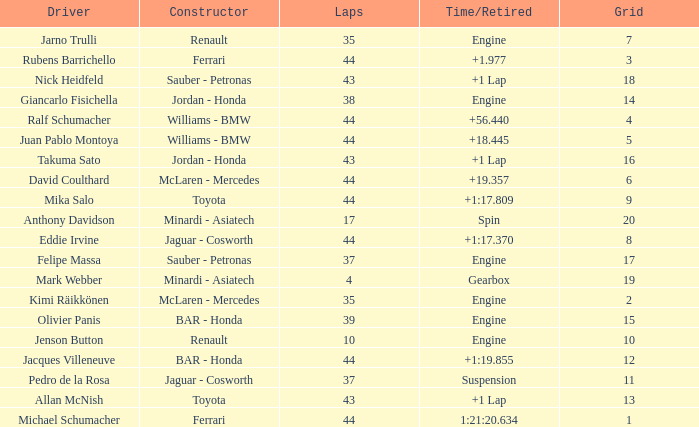What was the fewest laps for somone who finished +18.445? 44.0. Parse the full table. {'header': ['Driver', 'Constructor', 'Laps', 'Time/Retired', 'Grid'], 'rows': [['Jarno Trulli', 'Renault', '35', 'Engine', '7'], ['Rubens Barrichello', 'Ferrari', '44', '+1.977', '3'], ['Nick Heidfeld', 'Sauber - Petronas', '43', '+1 Lap', '18'], ['Giancarlo Fisichella', 'Jordan - Honda', '38', 'Engine', '14'], ['Ralf Schumacher', 'Williams - BMW', '44', '+56.440', '4'], ['Juan Pablo Montoya', 'Williams - BMW', '44', '+18.445', '5'], ['Takuma Sato', 'Jordan - Honda', '43', '+1 Lap', '16'], ['David Coulthard', 'McLaren - Mercedes', '44', '+19.357', '6'], ['Mika Salo', 'Toyota', '44', '+1:17.809', '9'], ['Anthony Davidson', 'Minardi - Asiatech', '17', 'Spin', '20'], ['Eddie Irvine', 'Jaguar - Cosworth', '44', '+1:17.370', '8'], ['Felipe Massa', 'Sauber - Petronas', '37', 'Engine', '17'], ['Mark Webber', 'Minardi - Asiatech', '4', 'Gearbox', '19'], ['Kimi Räikkönen', 'McLaren - Mercedes', '35', 'Engine', '2'], ['Olivier Panis', 'BAR - Honda', '39', 'Engine', '15'], ['Jenson Button', 'Renault', '10', 'Engine', '10'], ['Jacques Villeneuve', 'BAR - Honda', '44', '+1:19.855', '12'], ['Pedro de la Rosa', 'Jaguar - Cosworth', '37', 'Suspension', '11'], ['Allan McNish', 'Toyota', '43', '+1 Lap', '13'], ['Michael Schumacher', 'Ferrari', '44', '1:21:20.634', '1']]} 